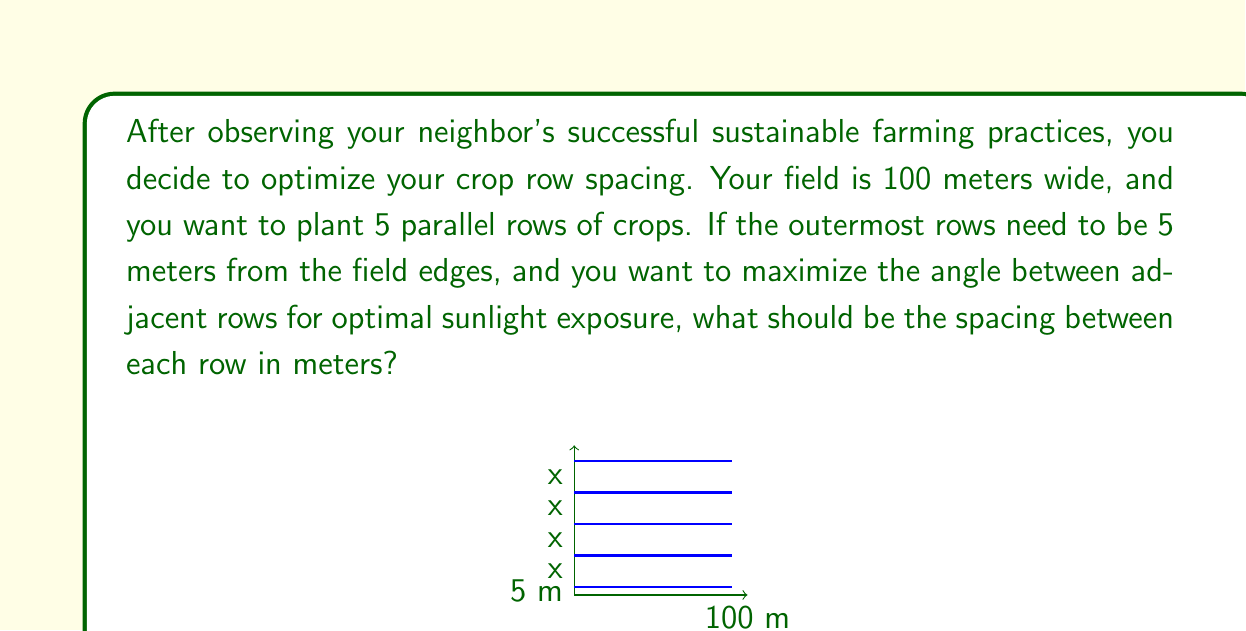Can you answer this question? Let's approach this step-by-step:

1) First, we need to understand the layout. We have 5 rows, with the outermost rows 5 meters from each edge. This leaves us with 4 spaces between the rows.

2) The total width of the field is 100 meters. We can set up an equation:

   $5 + 5 + 4x = 100$

   Where $x$ is the spacing between each row.

3) Simplify the equation:
   $10 + 4x = 100$
   $4x = 90$

4) Solve for $x$:
   $x = 90 / 4 = 22.5$

5) To verify if this maximizes the angle between adjacent rows, we can consider that equal spacing will indeed result in the maximum angle. This is because if any spacing were larger, another would have to be smaller, resulting in a smaller minimum angle.

6) The angle between rows can be calculated using the arctangent function:

   $\theta = \arctan(\frac{22.5}{100}) \approx 12.68°$

   This angle is the same between all adjacent rows, confirming optimal spacing for sunlight exposure.

Therefore, the optimal spacing between each row is 22.5 meters.
Answer: 22.5 meters 